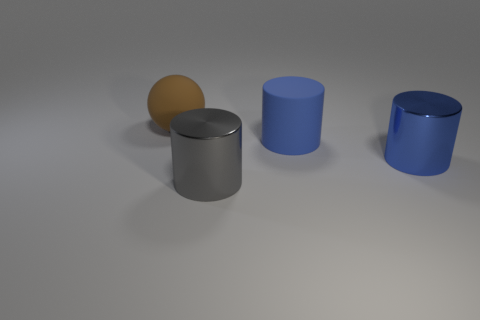In terms of arrangement, how are the objects positioned relative to each other? The objects in the image, including two blue cylinders, one gray cylinder, and one beige sphere, are arranged in a staggered line. They are spaced out evenly, suggesting a deliberate placement with an emphasis on symmetry and balance. 